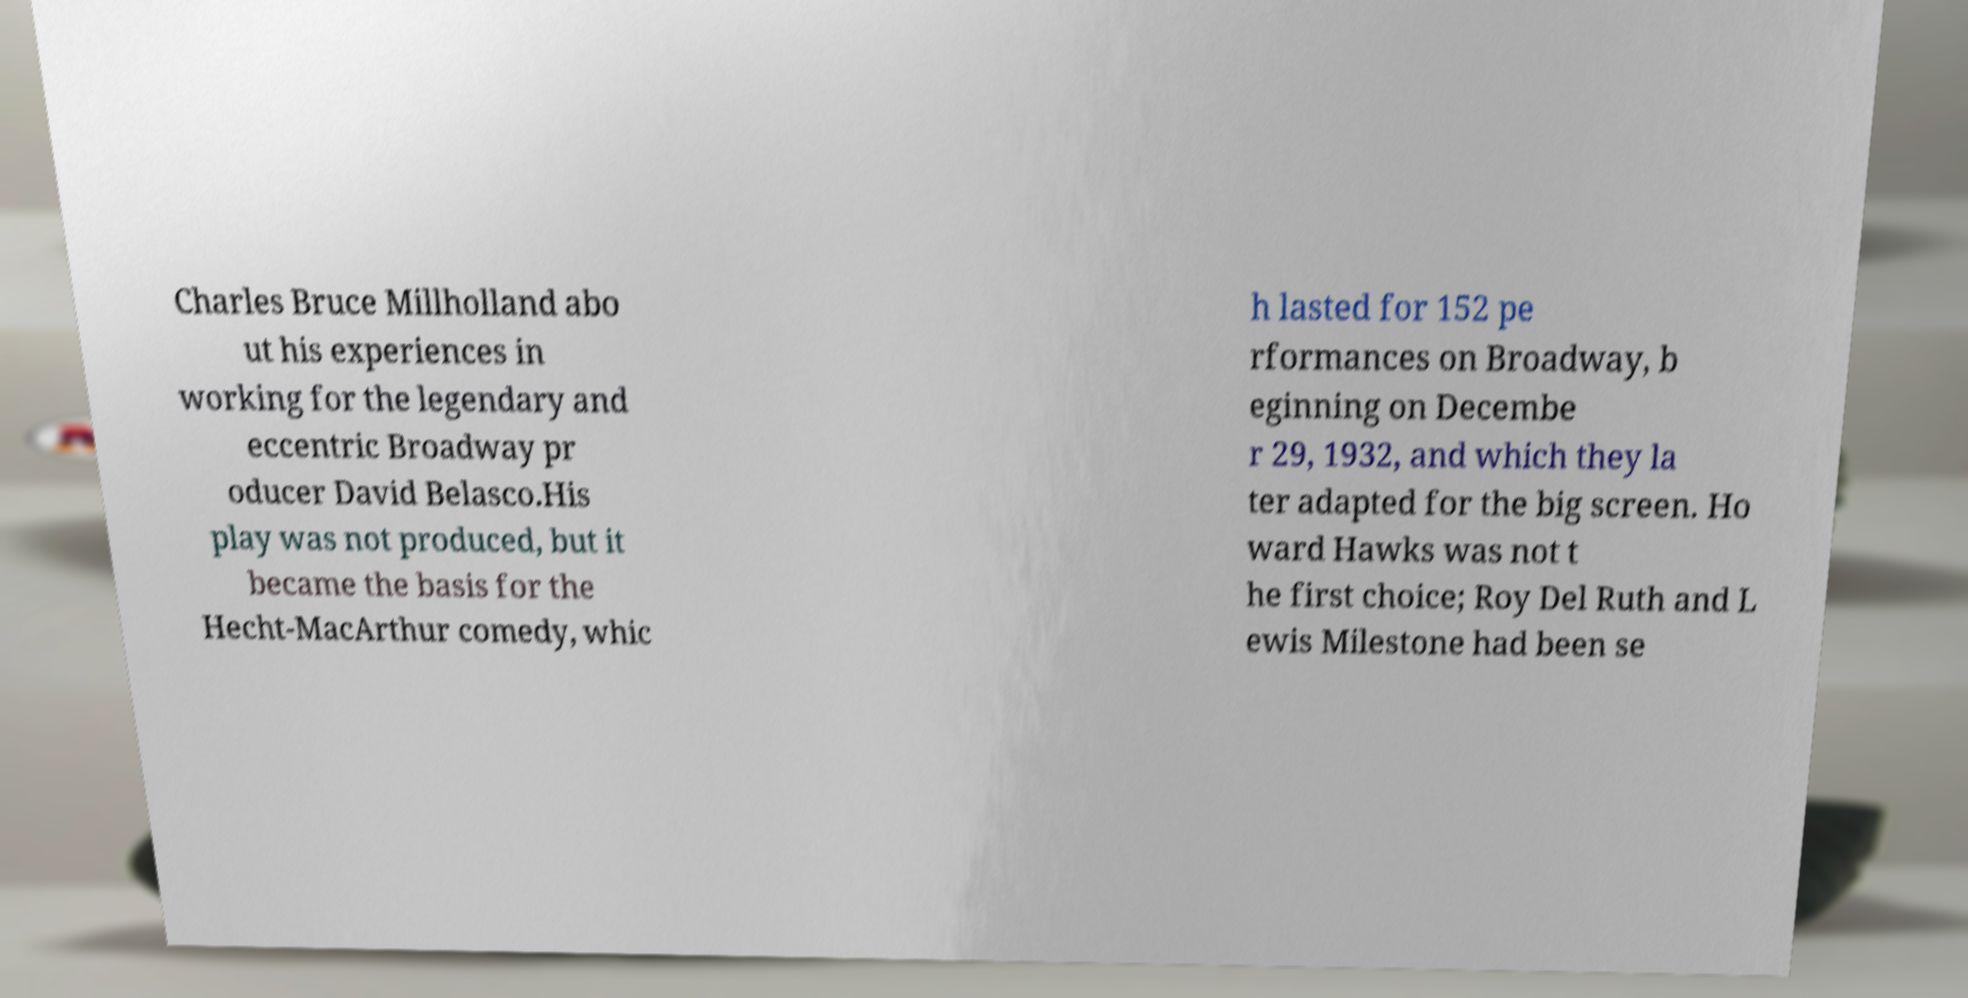Can you accurately transcribe the text from the provided image for me? Charles Bruce Millholland abo ut his experiences in working for the legendary and eccentric Broadway pr oducer David Belasco.His play was not produced, but it became the basis for the Hecht-MacArthur comedy, whic h lasted for 152 pe rformances on Broadway, b eginning on Decembe r 29, 1932, and which they la ter adapted for the big screen. Ho ward Hawks was not t he first choice; Roy Del Ruth and L ewis Milestone had been se 